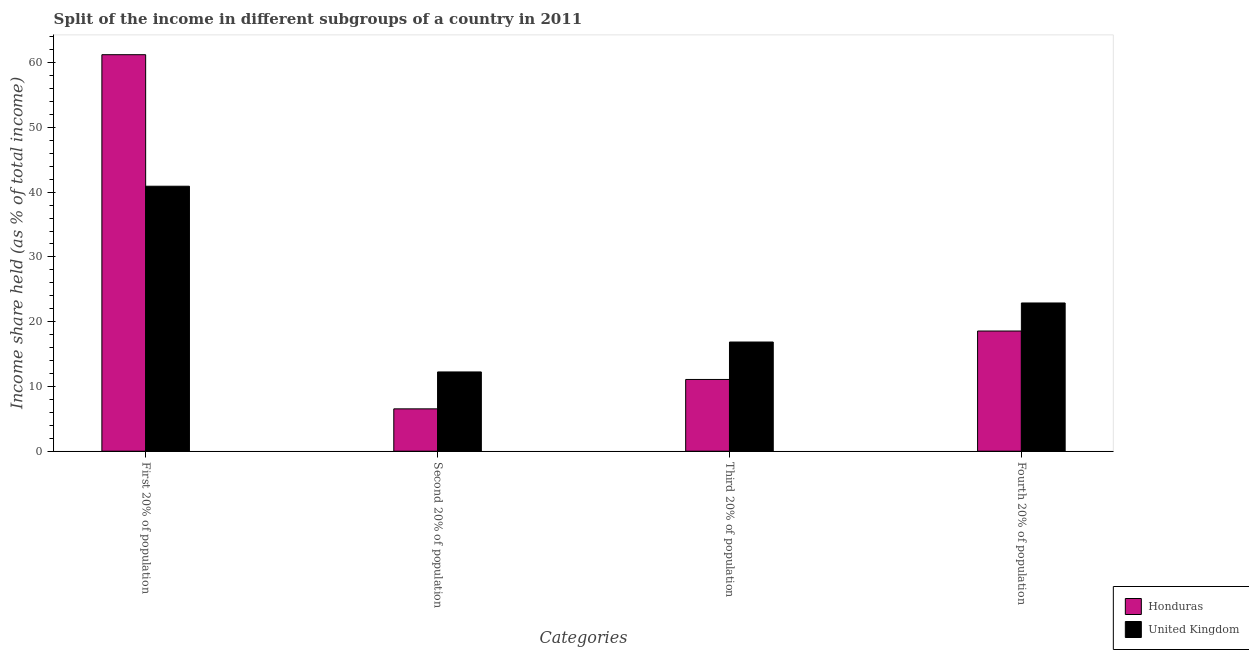Are the number of bars on each tick of the X-axis equal?
Give a very brief answer. Yes. How many bars are there on the 4th tick from the left?
Make the answer very short. 2. What is the label of the 2nd group of bars from the left?
Your response must be concise. Second 20% of population. What is the share of the income held by fourth 20% of the population in Honduras?
Your answer should be compact. 18.56. Across all countries, what is the maximum share of the income held by second 20% of the population?
Offer a very short reply. 12.24. Across all countries, what is the minimum share of the income held by second 20% of the population?
Your answer should be compact. 6.54. In which country was the share of the income held by fourth 20% of the population maximum?
Ensure brevity in your answer.  United Kingdom. In which country was the share of the income held by third 20% of the population minimum?
Your answer should be very brief. Honduras. What is the total share of the income held by second 20% of the population in the graph?
Your answer should be very brief. 18.78. What is the difference between the share of the income held by first 20% of the population in Honduras and that in United Kingdom?
Keep it short and to the point. 20.31. What is the difference between the share of the income held by fourth 20% of the population in Honduras and the share of the income held by third 20% of the population in United Kingdom?
Ensure brevity in your answer.  1.7. What is the average share of the income held by fourth 20% of the population per country?
Make the answer very short. 20.73. What is the difference between the share of the income held by third 20% of the population and share of the income held by first 20% of the population in Honduras?
Offer a terse response. -50.15. In how many countries, is the share of the income held by second 20% of the population greater than 4 %?
Offer a terse response. 2. What is the ratio of the share of the income held by fourth 20% of the population in Honduras to that in United Kingdom?
Ensure brevity in your answer.  0.81. Is the difference between the share of the income held by first 20% of the population in United Kingdom and Honduras greater than the difference between the share of the income held by fourth 20% of the population in United Kingdom and Honduras?
Provide a succinct answer. No. What is the difference between the highest and the second highest share of the income held by third 20% of the population?
Your response must be concise. 5.78. What is the difference between the highest and the lowest share of the income held by third 20% of the population?
Ensure brevity in your answer.  5.78. Is the sum of the share of the income held by second 20% of the population in Honduras and United Kingdom greater than the maximum share of the income held by fourth 20% of the population across all countries?
Make the answer very short. No. What does the 2nd bar from the left in Second 20% of population represents?
Ensure brevity in your answer.  United Kingdom. How many bars are there?
Offer a very short reply. 8. How many countries are there in the graph?
Keep it short and to the point. 2. What is the difference between two consecutive major ticks on the Y-axis?
Make the answer very short. 10. Are the values on the major ticks of Y-axis written in scientific E-notation?
Ensure brevity in your answer.  No. Does the graph contain grids?
Keep it short and to the point. No. How many legend labels are there?
Offer a terse response. 2. What is the title of the graph?
Your answer should be very brief. Split of the income in different subgroups of a country in 2011. What is the label or title of the X-axis?
Give a very brief answer. Categories. What is the label or title of the Y-axis?
Keep it short and to the point. Income share held (as % of total income). What is the Income share held (as % of total income) of Honduras in First 20% of population?
Provide a short and direct response. 61.23. What is the Income share held (as % of total income) of United Kingdom in First 20% of population?
Keep it short and to the point. 40.92. What is the Income share held (as % of total income) in Honduras in Second 20% of population?
Offer a terse response. 6.54. What is the Income share held (as % of total income) of United Kingdom in Second 20% of population?
Your response must be concise. 12.24. What is the Income share held (as % of total income) of Honduras in Third 20% of population?
Keep it short and to the point. 11.08. What is the Income share held (as % of total income) in United Kingdom in Third 20% of population?
Provide a succinct answer. 16.86. What is the Income share held (as % of total income) of Honduras in Fourth 20% of population?
Your answer should be very brief. 18.56. What is the Income share held (as % of total income) in United Kingdom in Fourth 20% of population?
Provide a short and direct response. 22.89. Across all Categories, what is the maximum Income share held (as % of total income) in Honduras?
Provide a short and direct response. 61.23. Across all Categories, what is the maximum Income share held (as % of total income) of United Kingdom?
Offer a terse response. 40.92. Across all Categories, what is the minimum Income share held (as % of total income) in Honduras?
Your response must be concise. 6.54. Across all Categories, what is the minimum Income share held (as % of total income) in United Kingdom?
Your response must be concise. 12.24. What is the total Income share held (as % of total income) of Honduras in the graph?
Keep it short and to the point. 97.41. What is the total Income share held (as % of total income) of United Kingdom in the graph?
Your answer should be very brief. 92.91. What is the difference between the Income share held (as % of total income) in Honduras in First 20% of population and that in Second 20% of population?
Give a very brief answer. 54.69. What is the difference between the Income share held (as % of total income) of United Kingdom in First 20% of population and that in Second 20% of population?
Provide a short and direct response. 28.68. What is the difference between the Income share held (as % of total income) in Honduras in First 20% of population and that in Third 20% of population?
Give a very brief answer. 50.15. What is the difference between the Income share held (as % of total income) in United Kingdom in First 20% of population and that in Third 20% of population?
Offer a very short reply. 24.06. What is the difference between the Income share held (as % of total income) of Honduras in First 20% of population and that in Fourth 20% of population?
Keep it short and to the point. 42.67. What is the difference between the Income share held (as % of total income) of United Kingdom in First 20% of population and that in Fourth 20% of population?
Your answer should be compact. 18.03. What is the difference between the Income share held (as % of total income) in Honduras in Second 20% of population and that in Third 20% of population?
Keep it short and to the point. -4.54. What is the difference between the Income share held (as % of total income) in United Kingdom in Second 20% of population and that in Third 20% of population?
Provide a short and direct response. -4.62. What is the difference between the Income share held (as % of total income) in Honduras in Second 20% of population and that in Fourth 20% of population?
Offer a terse response. -12.02. What is the difference between the Income share held (as % of total income) of United Kingdom in Second 20% of population and that in Fourth 20% of population?
Provide a succinct answer. -10.65. What is the difference between the Income share held (as % of total income) of Honduras in Third 20% of population and that in Fourth 20% of population?
Provide a short and direct response. -7.48. What is the difference between the Income share held (as % of total income) in United Kingdom in Third 20% of population and that in Fourth 20% of population?
Provide a short and direct response. -6.03. What is the difference between the Income share held (as % of total income) in Honduras in First 20% of population and the Income share held (as % of total income) in United Kingdom in Second 20% of population?
Give a very brief answer. 48.99. What is the difference between the Income share held (as % of total income) in Honduras in First 20% of population and the Income share held (as % of total income) in United Kingdom in Third 20% of population?
Your answer should be very brief. 44.37. What is the difference between the Income share held (as % of total income) of Honduras in First 20% of population and the Income share held (as % of total income) of United Kingdom in Fourth 20% of population?
Ensure brevity in your answer.  38.34. What is the difference between the Income share held (as % of total income) in Honduras in Second 20% of population and the Income share held (as % of total income) in United Kingdom in Third 20% of population?
Offer a very short reply. -10.32. What is the difference between the Income share held (as % of total income) in Honduras in Second 20% of population and the Income share held (as % of total income) in United Kingdom in Fourth 20% of population?
Give a very brief answer. -16.35. What is the difference between the Income share held (as % of total income) of Honduras in Third 20% of population and the Income share held (as % of total income) of United Kingdom in Fourth 20% of population?
Offer a very short reply. -11.81. What is the average Income share held (as % of total income) of Honduras per Categories?
Ensure brevity in your answer.  24.35. What is the average Income share held (as % of total income) of United Kingdom per Categories?
Provide a succinct answer. 23.23. What is the difference between the Income share held (as % of total income) in Honduras and Income share held (as % of total income) in United Kingdom in First 20% of population?
Provide a short and direct response. 20.31. What is the difference between the Income share held (as % of total income) of Honduras and Income share held (as % of total income) of United Kingdom in Third 20% of population?
Your answer should be compact. -5.78. What is the difference between the Income share held (as % of total income) in Honduras and Income share held (as % of total income) in United Kingdom in Fourth 20% of population?
Provide a short and direct response. -4.33. What is the ratio of the Income share held (as % of total income) of Honduras in First 20% of population to that in Second 20% of population?
Provide a succinct answer. 9.36. What is the ratio of the Income share held (as % of total income) in United Kingdom in First 20% of population to that in Second 20% of population?
Make the answer very short. 3.34. What is the ratio of the Income share held (as % of total income) of Honduras in First 20% of population to that in Third 20% of population?
Your response must be concise. 5.53. What is the ratio of the Income share held (as % of total income) of United Kingdom in First 20% of population to that in Third 20% of population?
Keep it short and to the point. 2.43. What is the ratio of the Income share held (as % of total income) of Honduras in First 20% of population to that in Fourth 20% of population?
Your answer should be very brief. 3.3. What is the ratio of the Income share held (as % of total income) of United Kingdom in First 20% of population to that in Fourth 20% of population?
Provide a short and direct response. 1.79. What is the ratio of the Income share held (as % of total income) of Honduras in Second 20% of population to that in Third 20% of population?
Provide a short and direct response. 0.59. What is the ratio of the Income share held (as % of total income) in United Kingdom in Second 20% of population to that in Third 20% of population?
Offer a very short reply. 0.73. What is the ratio of the Income share held (as % of total income) of Honduras in Second 20% of population to that in Fourth 20% of population?
Provide a short and direct response. 0.35. What is the ratio of the Income share held (as % of total income) of United Kingdom in Second 20% of population to that in Fourth 20% of population?
Give a very brief answer. 0.53. What is the ratio of the Income share held (as % of total income) of Honduras in Third 20% of population to that in Fourth 20% of population?
Provide a short and direct response. 0.6. What is the ratio of the Income share held (as % of total income) of United Kingdom in Third 20% of population to that in Fourth 20% of population?
Provide a succinct answer. 0.74. What is the difference between the highest and the second highest Income share held (as % of total income) of Honduras?
Make the answer very short. 42.67. What is the difference between the highest and the second highest Income share held (as % of total income) of United Kingdom?
Offer a very short reply. 18.03. What is the difference between the highest and the lowest Income share held (as % of total income) of Honduras?
Offer a very short reply. 54.69. What is the difference between the highest and the lowest Income share held (as % of total income) of United Kingdom?
Provide a short and direct response. 28.68. 